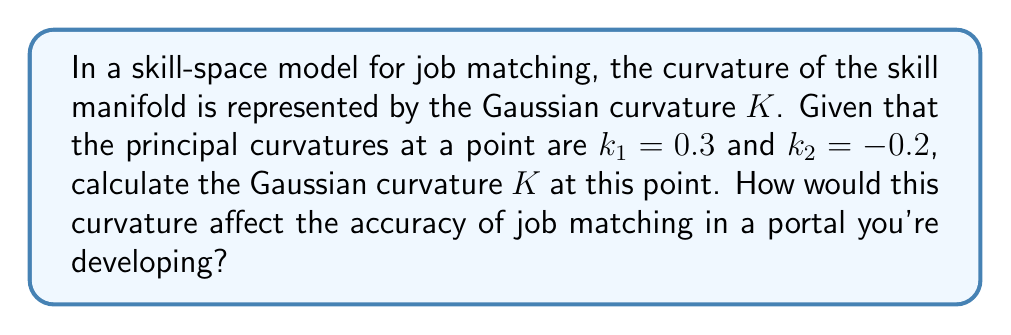Could you help me with this problem? Let's approach this step-by-step:

1) In differential geometry, the Gaussian curvature $K$ at a point on a surface is defined as the product of the principal curvatures at that point:

   $$K = k_1 \cdot k_2$$

2) We are given that:
   $k_1 = 0.3$
   $k_2 = -0.2$

3) Substituting these values into the formula:

   $$K = 0.3 \cdot (-0.2) = -0.06$$

4) Therefore, the Gaussian curvature at this point is $-0.06$.

5) Interpretation for job matching accuracy:
   - A negative Gaussian curvature indicates a saddle-like shape in the skill-space at this point.
   - This means that in one direction, skills are becoming more specialized (positive curvature), while in the perpendicular direction, they are becoming more generalized (negative curvature).
   - For a job portal, this implies that at this point in the skill-space, candidates might have a mix of specialized and generalized skills.
   - To improve matching accuracy, the algorithm should consider this curvature:
     a) Look for jobs that require a combination of specialized skills in one area and broader skills in another.
     b) Avoid over-emphasizing exact skill matches, as the curved space suggests some flexibility in skill combinations.
     c) Implement non-linear distance metrics in the matching algorithm to account for the curved nature of the skill-space.

By incorporating this curvature information, the job portal can provide more nuanced and accurate matches between job seekers and positions, recognizing the complex interplay of skills in this region of the skill-space.
Answer: $K = -0.06$; Indicates saddle point in skill-space; Improve matching by considering skill flexibility and using non-linear distance metrics. 